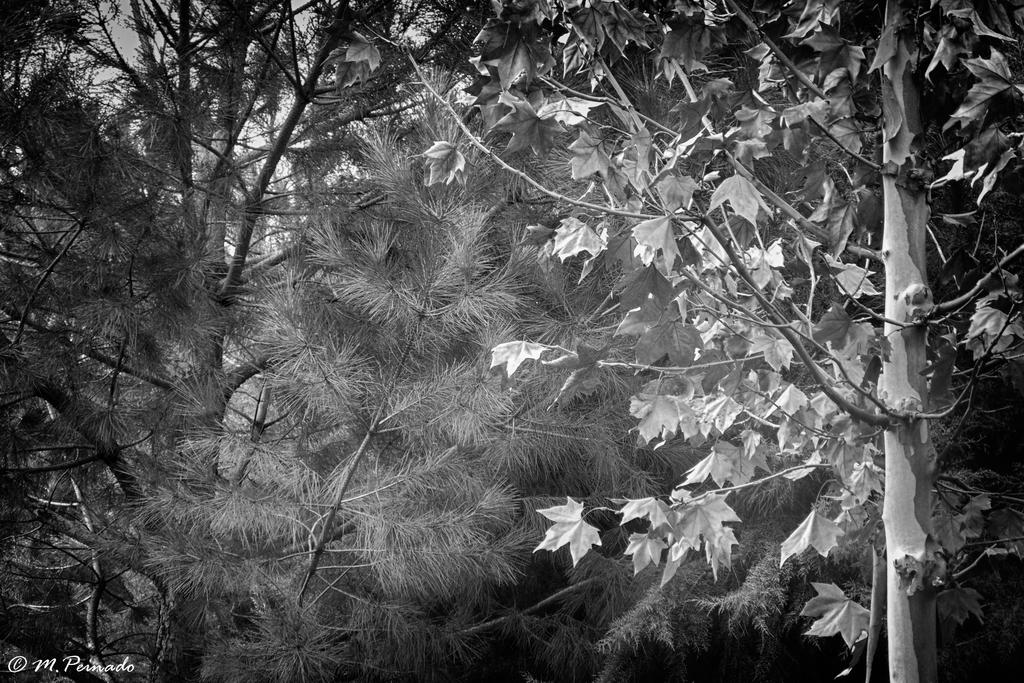What is the color scheme of the image? The image is black and white. What type of natural elements can be seen in the image? There are trees in the image. Is there any text or logo visible on the image? Yes, there is a watermark on the image. What type of animal is sitting next to dad in the image? There is no animal or dad present in the image; it only features trees and a watermark. 